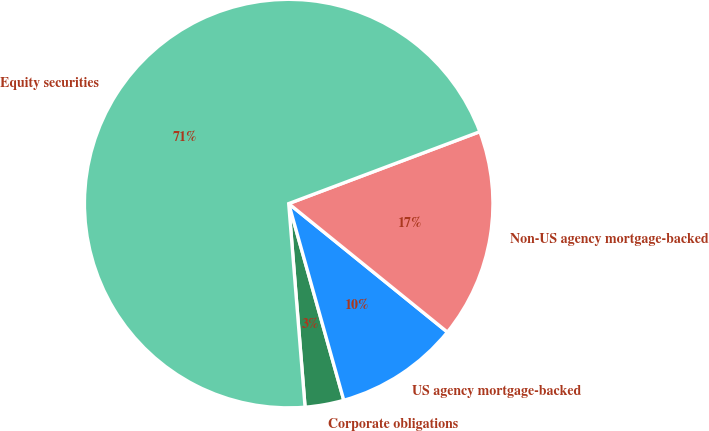Convert chart to OTSL. <chart><loc_0><loc_0><loc_500><loc_500><pie_chart><fcel>Corporate obligations<fcel>US agency mortgage-backed<fcel>Non-US agency mortgage-backed<fcel>Equity securities<nl><fcel>3.07%<fcel>9.82%<fcel>16.56%<fcel>70.55%<nl></chart> 